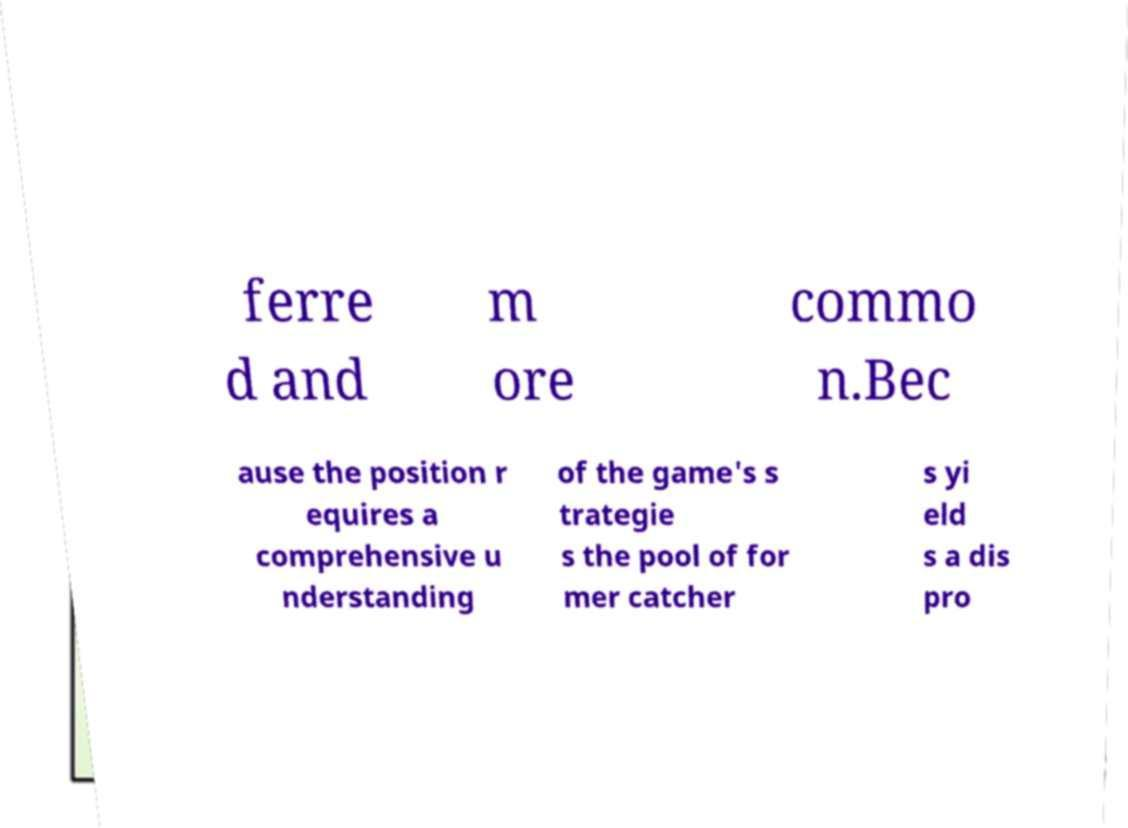There's text embedded in this image that I need extracted. Can you transcribe it verbatim? ferre d and m ore commo n.Bec ause the position r equires a comprehensive u nderstanding of the game's s trategie s the pool of for mer catcher s yi eld s a dis pro 